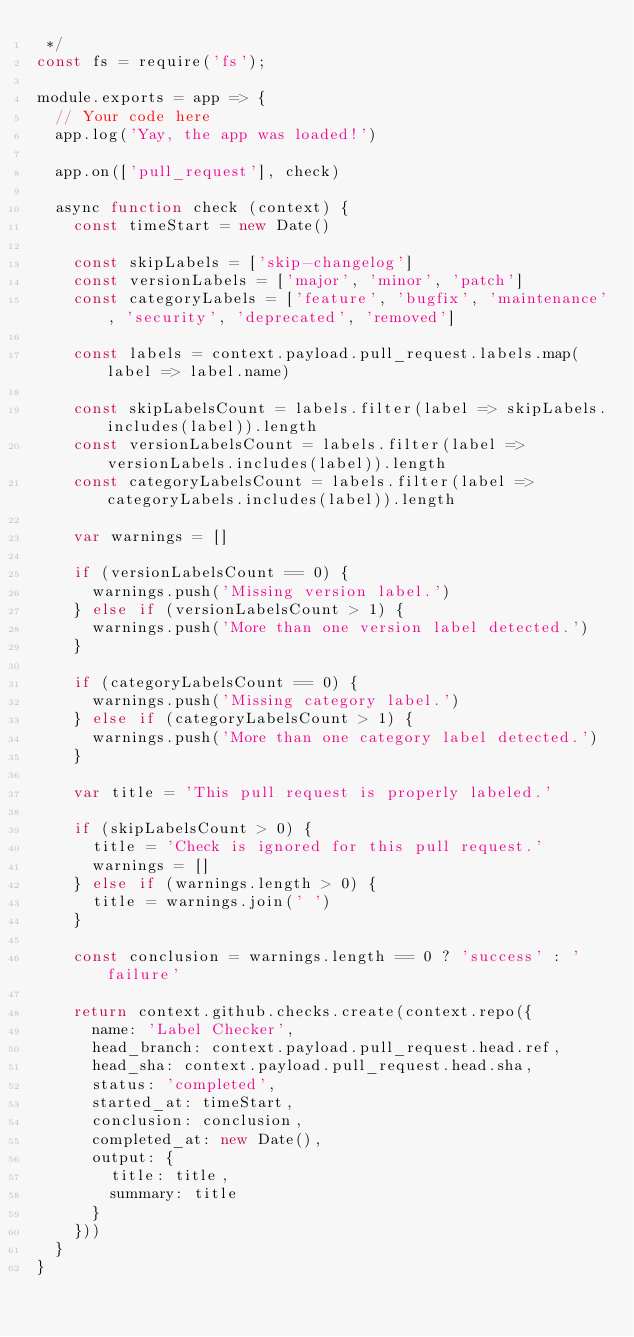Convert code to text. <code><loc_0><loc_0><loc_500><loc_500><_JavaScript_> */
const fs = require('fs');

module.exports = app => {
  // Your code here
  app.log('Yay, the app was loaded!')

  app.on(['pull_request'], check)

  async function check (context) {
    const timeStart = new Date()

    const skipLabels = ['skip-changelog']
    const versionLabels = ['major', 'minor', 'patch']
    const categoryLabels = ['feature', 'bugfix', 'maintenance', 'security', 'deprecated', 'removed']

    const labels = context.payload.pull_request.labels.map(label => label.name)
    
    const skipLabelsCount = labels.filter(label => skipLabels.includes(label)).length
    const versionLabelsCount = labels.filter(label => versionLabels.includes(label)).length
    const categoryLabelsCount = labels.filter(label => categoryLabels.includes(label)).length

    var warnings = []

    if (versionLabelsCount == 0) {
      warnings.push('Missing version label.')
    } else if (versionLabelsCount > 1) {
      warnings.push('More than one version label detected.')
    }

    if (categoryLabelsCount == 0) {
      warnings.push('Missing category label.')
    } else if (categoryLabelsCount > 1) {
      warnings.push('More than one category label detected.')
    }

    var title = 'This pull request is properly labeled.'

    if (skipLabelsCount > 0) {
      title = 'Check is ignored for this pull request.'
      warnings = [] 
    } else if (warnings.length > 0) {
      title = warnings.join(' ')
    }

    const conclusion = warnings.length == 0 ? 'success' : 'failure'

    return context.github.checks.create(context.repo({
      name: 'Label Checker',
      head_branch: context.payload.pull_request.head.ref,
      head_sha: context.payload.pull_request.head.sha,
      status: 'completed',
      started_at: timeStart,
      conclusion: conclusion,
      completed_at: new Date(),
      output: {
        title: title,
        summary: title
      }
    }))
  }
}</code> 